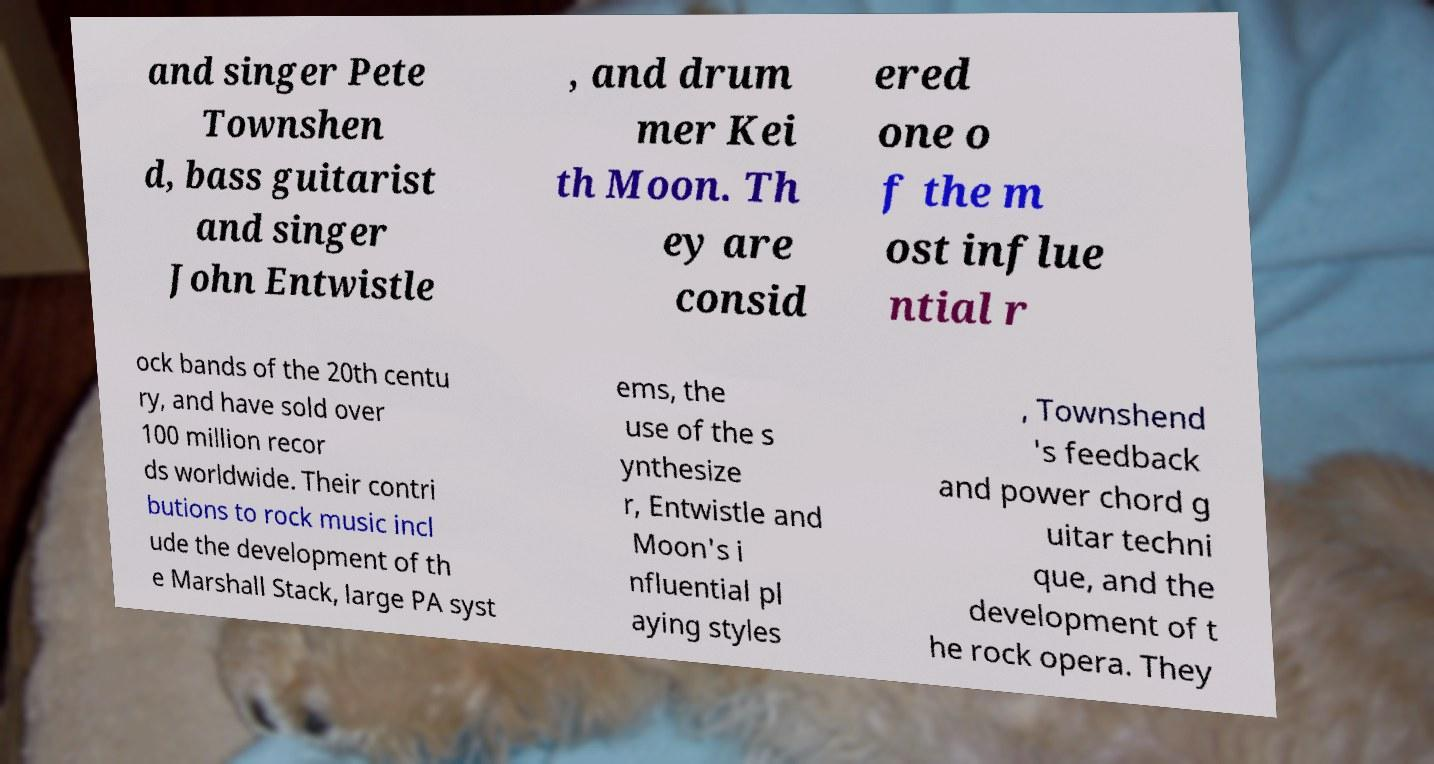Could you assist in decoding the text presented in this image and type it out clearly? and singer Pete Townshen d, bass guitarist and singer John Entwistle , and drum mer Kei th Moon. Th ey are consid ered one o f the m ost influe ntial r ock bands of the 20th centu ry, and have sold over 100 million recor ds worldwide. Their contri butions to rock music incl ude the development of th e Marshall Stack, large PA syst ems, the use of the s ynthesize r, Entwistle and Moon's i nfluential pl aying styles , Townshend 's feedback and power chord g uitar techni que, and the development of t he rock opera. They 